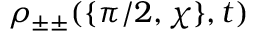Convert formula to latex. <formula><loc_0><loc_0><loc_500><loc_500>\rho _ { \pm \pm } ( \{ \pi / 2 , \chi \} , t )</formula> 